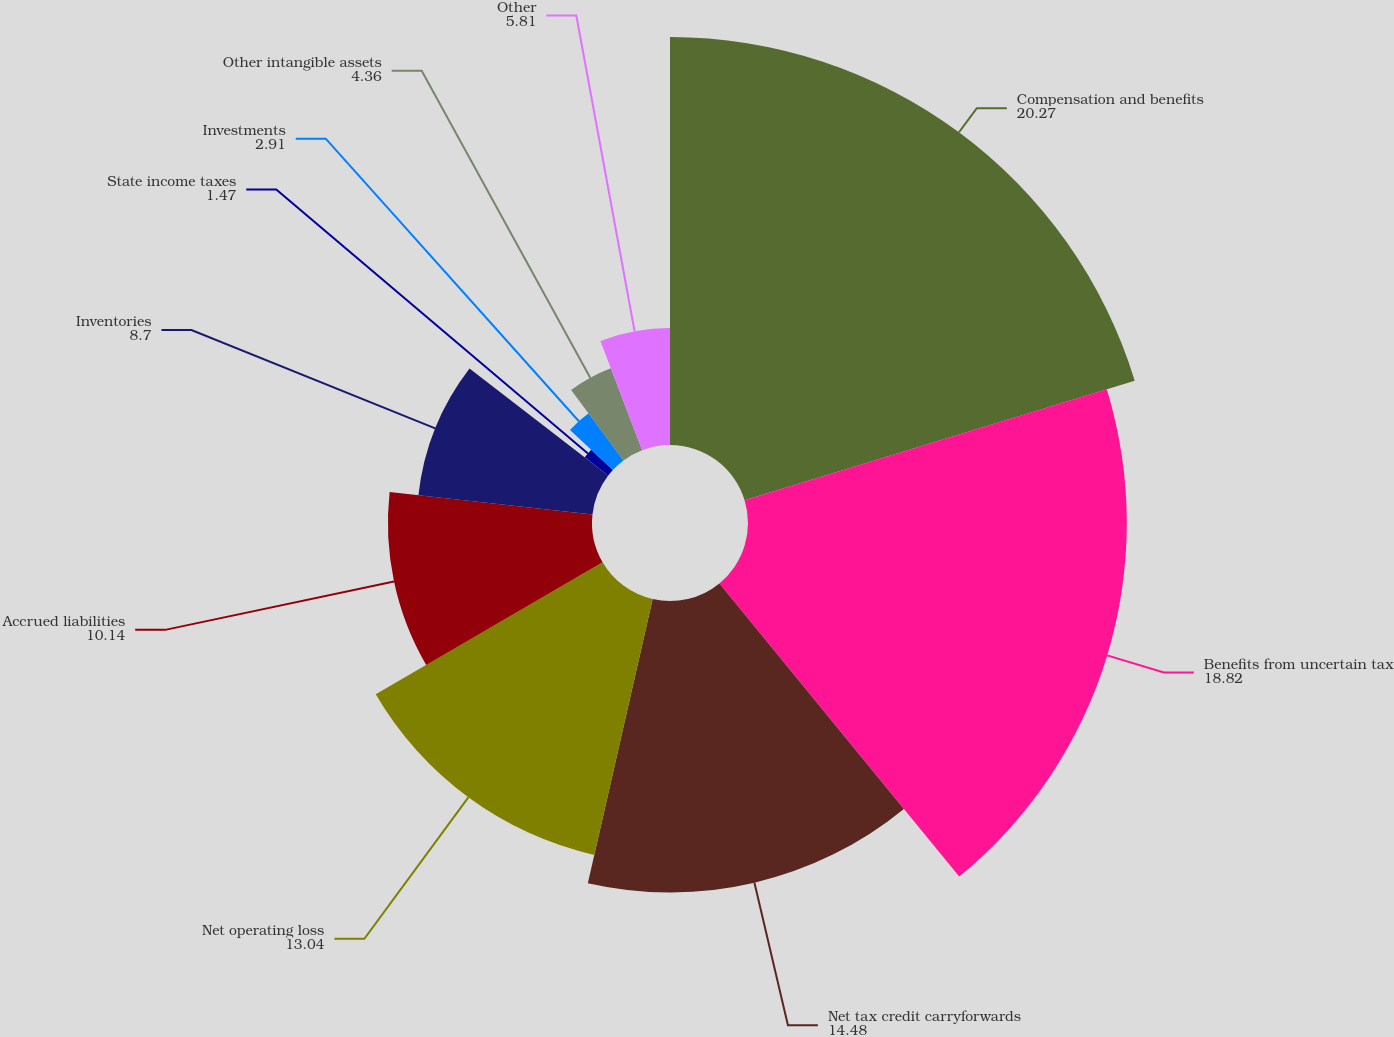Convert chart to OTSL. <chart><loc_0><loc_0><loc_500><loc_500><pie_chart><fcel>Compensation and benefits<fcel>Benefits from uncertain tax<fcel>Net tax credit carryforwards<fcel>Net operating loss<fcel>Accrued liabilities<fcel>Inventories<fcel>State income taxes<fcel>Investments<fcel>Other intangible assets<fcel>Other<nl><fcel>20.27%<fcel>18.82%<fcel>14.48%<fcel>13.04%<fcel>10.14%<fcel>8.7%<fcel>1.47%<fcel>2.91%<fcel>4.36%<fcel>5.81%<nl></chart> 